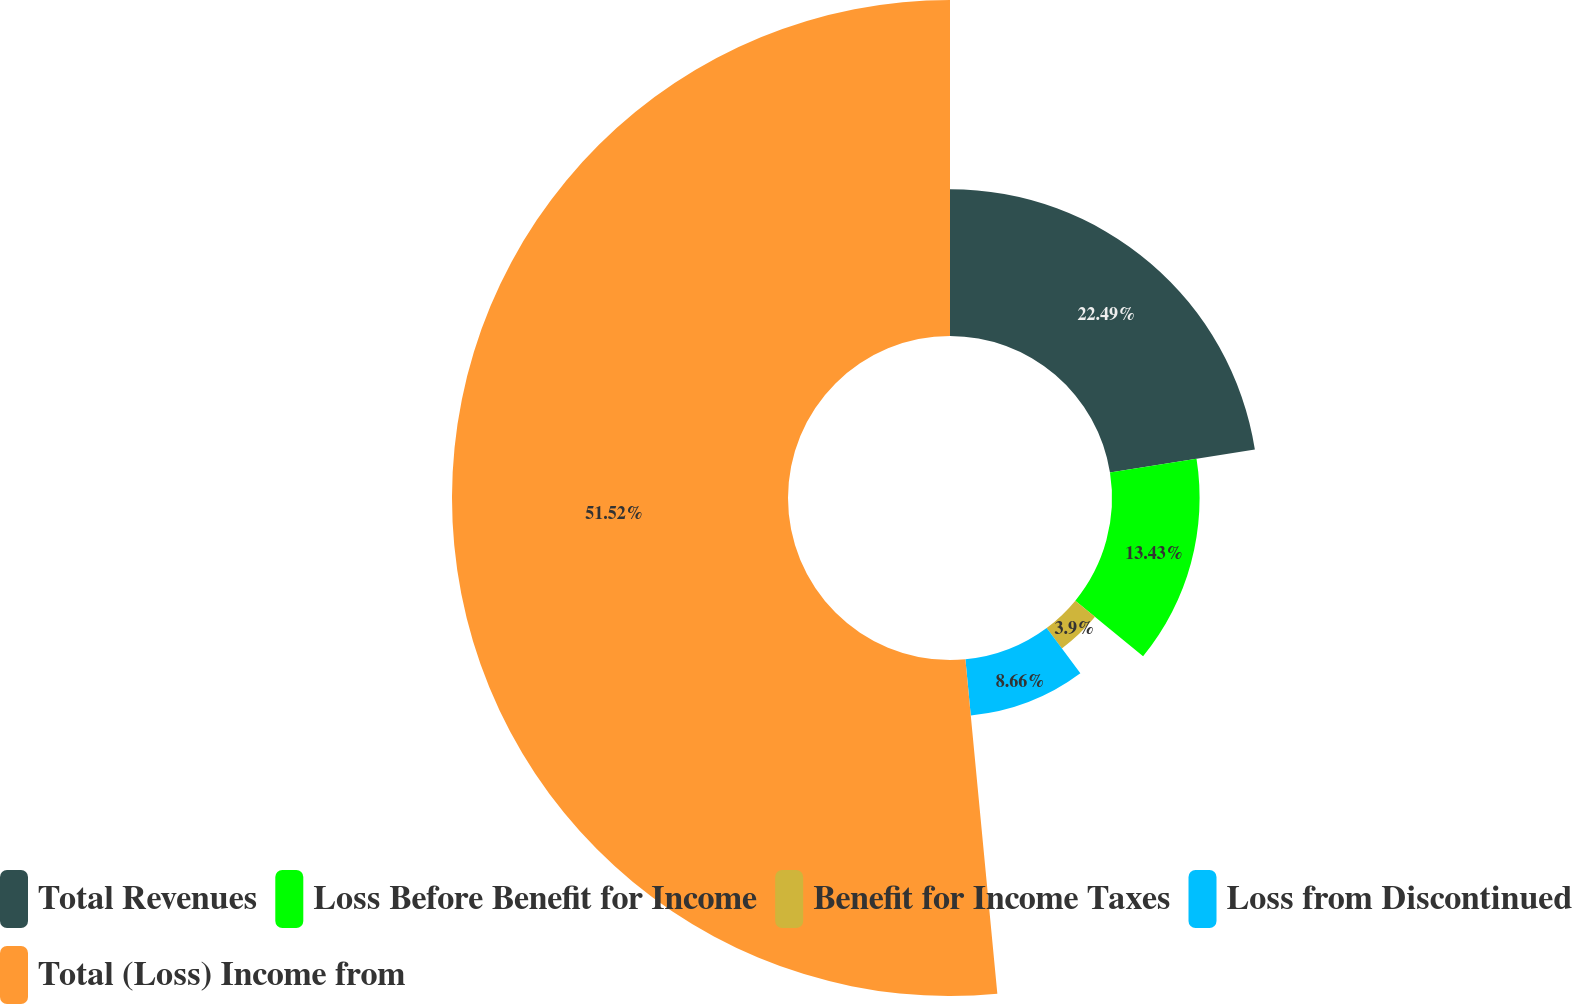<chart> <loc_0><loc_0><loc_500><loc_500><pie_chart><fcel>Total Revenues<fcel>Loss Before Benefit for Income<fcel>Benefit for Income Taxes<fcel>Loss from Discontinued<fcel>Total (Loss) Income from<nl><fcel>22.49%<fcel>13.43%<fcel>3.9%<fcel>8.66%<fcel>51.51%<nl></chart> 